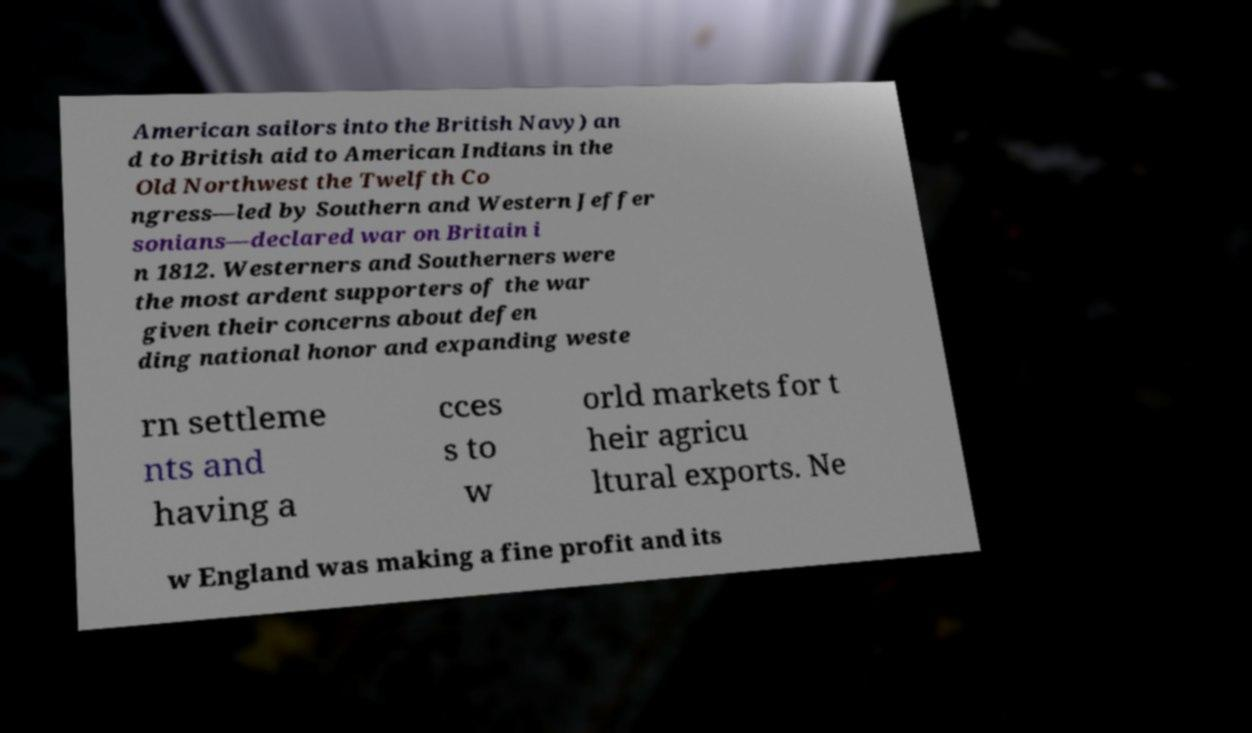Please read and relay the text visible in this image. What does it say? American sailors into the British Navy) an d to British aid to American Indians in the Old Northwest the Twelfth Co ngress—led by Southern and Western Jeffer sonians—declared war on Britain i n 1812. Westerners and Southerners were the most ardent supporters of the war given their concerns about defen ding national honor and expanding weste rn settleme nts and having a cces s to w orld markets for t heir agricu ltural exports. Ne w England was making a fine profit and its 